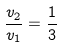<formula> <loc_0><loc_0><loc_500><loc_500>\frac { v _ { 2 } } { v _ { 1 } } = \frac { 1 } { 3 }</formula> 